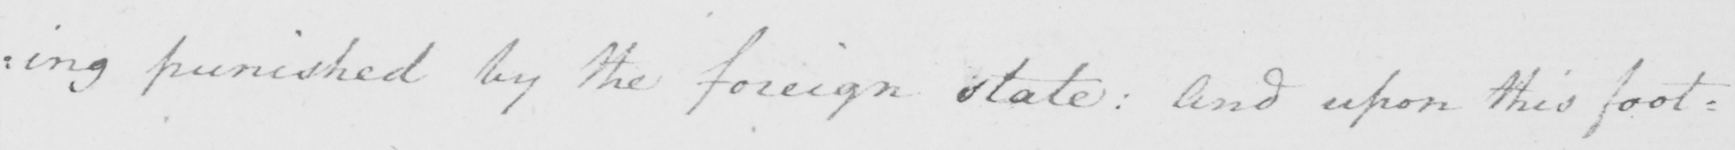Please transcribe the handwritten text in this image. : ing punished by the foreign state :  And upon this foot : 